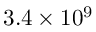Convert formula to latex. <formula><loc_0><loc_0><loc_500><loc_500>3 . 4 \times 1 0 ^ { 9 }</formula> 